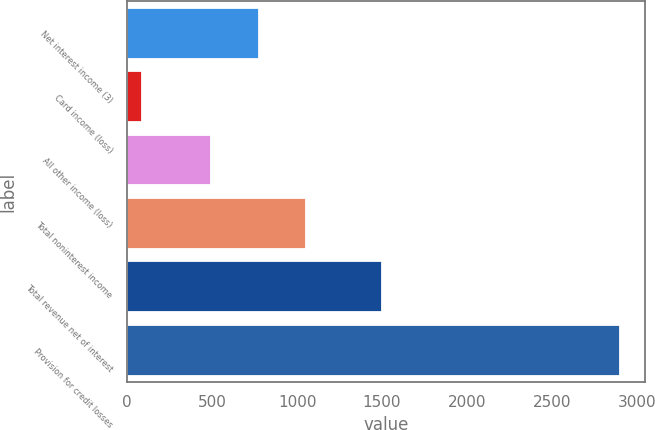Convert chart to OTSL. <chart><loc_0><loc_0><loc_500><loc_500><bar_chart><fcel>Net interest income (3)<fcel>Card income (loss)<fcel>All other income (loss)<fcel>Total noninterest income<fcel>Total revenue net of interest<fcel>Provision for credit losses<nl><fcel>773.5<fcel>86<fcel>492<fcel>1055<fcel>1502<fcel>2901<nl></chart> 